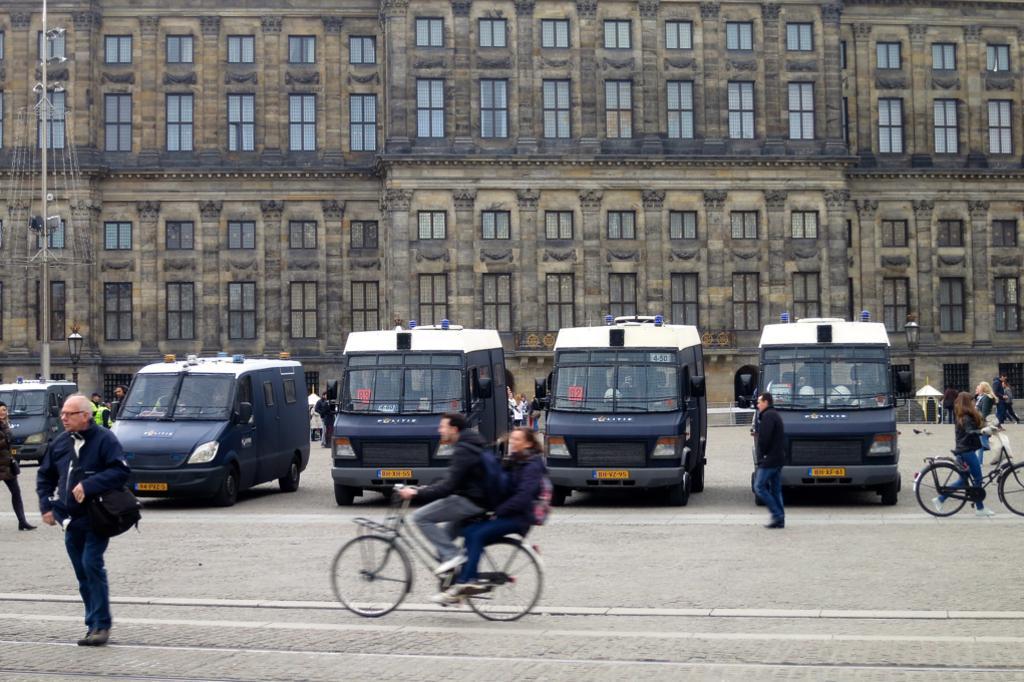How would you summarize this image in a sentence or two? In this image we can see persons standing on the road, persons riding bicycles, motor vehicles, buildings, street poles, street lights, parasols, windows and a fountain. 